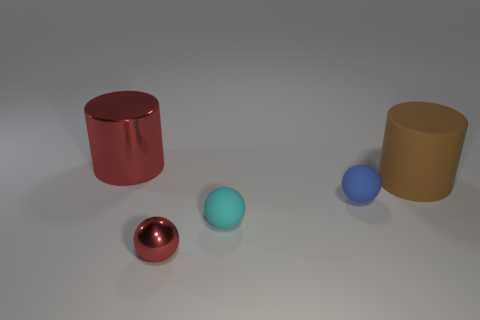Is the number of tiny objects behind the cyan matte sphere greater than the number of large red things in front of the red metallic cylinder?
Your answer should be very brief. Yes. Is there anything else that is the same color as the small metal sphere?
Offer a very short reply. Yes. There is a cylinder left of the tiny blue matte sphere; what is it made of?
Give a very brief answer. Metal. Do the metal ball and the brown matte cylinder have the same size?
Your answer should be very brief. No. What number of other things are there of the same size as the blue sphere?
Offer a very short reply. 2. Is the big metallic thing the same color as the small metallic thing?
Your response must be concise. Yes. What is the shape of the red metal thing that is on the left side of the metal thing that is in front of the object left of the tiny shiny thing?
Offer a terse response. Cylinder. How many objects are tiny blue rubber objects right of the small cyan object or red things behind the brown matte cylinder?
Provide a succinct answer. 2. There is a red metallic thing in front of the small matte object that is on the right side of the cyan matte object; what size is it?
Your answer should be compact. Small. There is a shiny thing that is in front of the large metallic cylinder; does it have the same color as the large metallic thing?
Provide a short and direct response. Yes. 